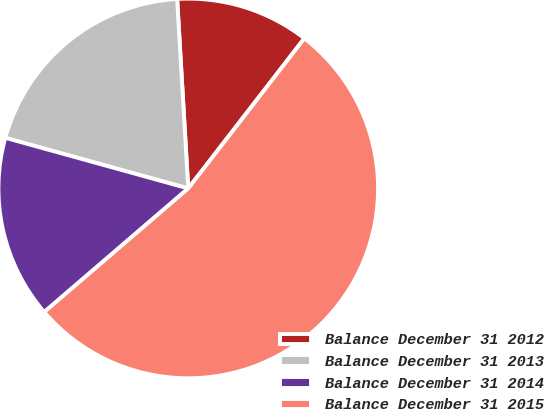Convert chart to OTSL. <chart><loc_0><loc_0><loc_500><loc_500><pie_chart><fcel>Balance December 31 2012<fcel>Balance December 31 2013<fcel>Balance December 31 2014<fcel>Balance December 31 2015<nl><fcel>11.41%<fcel>19.77%<fcel>15.59%<fcel>53.23%<nl></chart> 